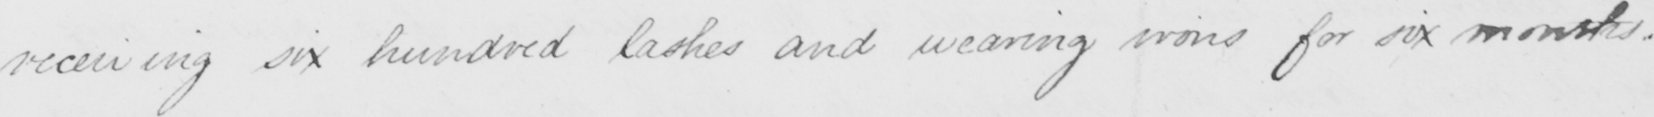What is written in this line of handwriting? receiving six hundred lashes and wearing irons for six months . 